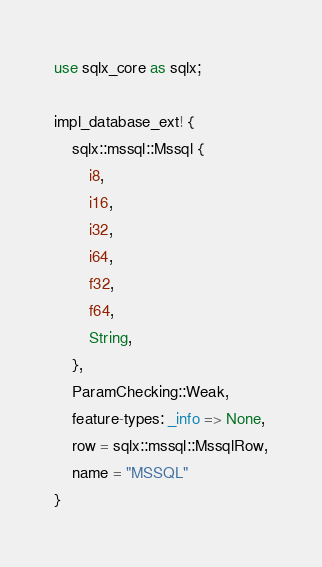Convert code to text. <code><loc_0><loc_0><loc_500><loc_500><_Rust_>use sqlx_core as sqlx;

impl_database_ext! {
    sqlx::mssql::Mssql {
        i8,
        i16,
        i32,
        i64,
        f32,
        f64,
        String,
    },
    ParamChecking::Weak,
    feature-types: _info => None,
    row = sqlx::mssql::MssqlRow,
    name = "MSSQL"
}
</code> 